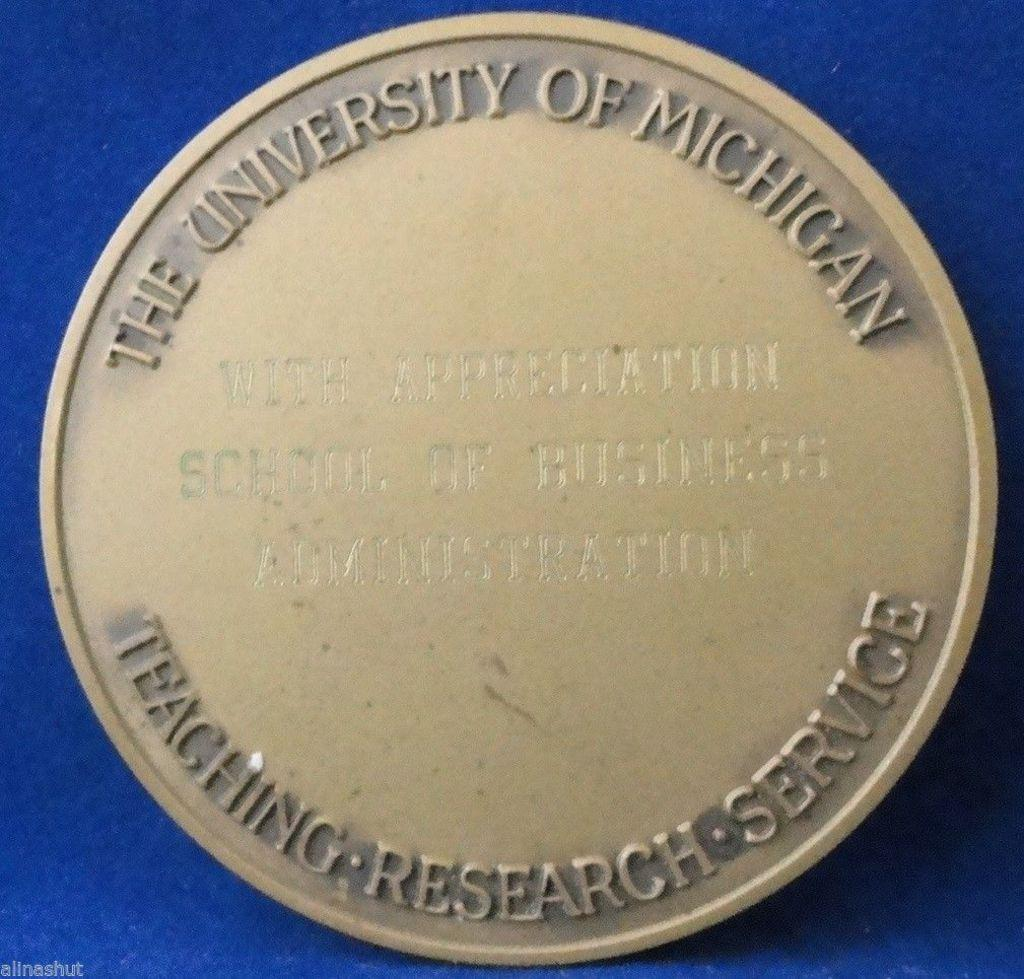<image>
Create a compact narrative representing the image presented. A medallion from the University of Michigan is on display on a blue background. 